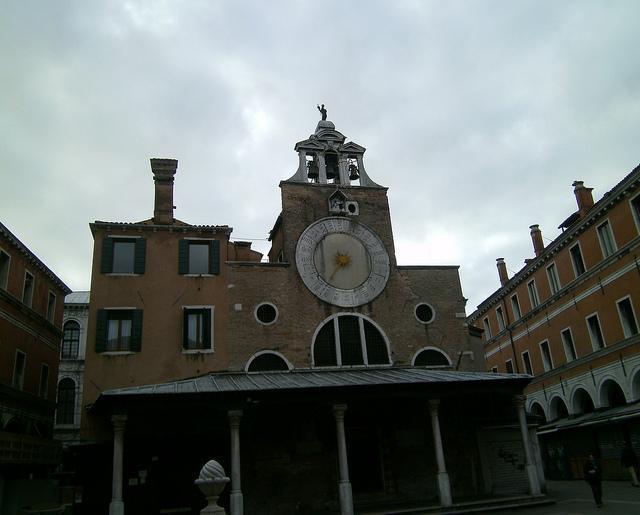How many clock faces?
Give a very brief answer. 1. How many clocks are there?
Give a very brief answer. 1. How many horses are adults in this image?
Give a very brief answer. 0. 